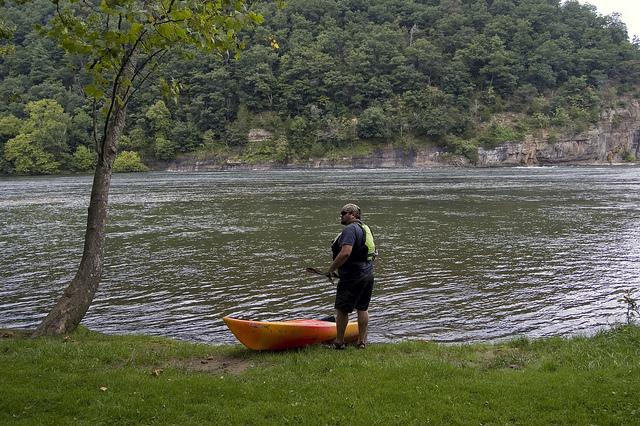Should there be water here?
Short answer required. Yes. What is the man standing beside?
Be succinct. Kayak. How many people are in the shot?
Short answer required. 1. What kind of boat is in the photo?
Quick response, please. Kayak. Is the grass green?
Be succinct. Yes. 